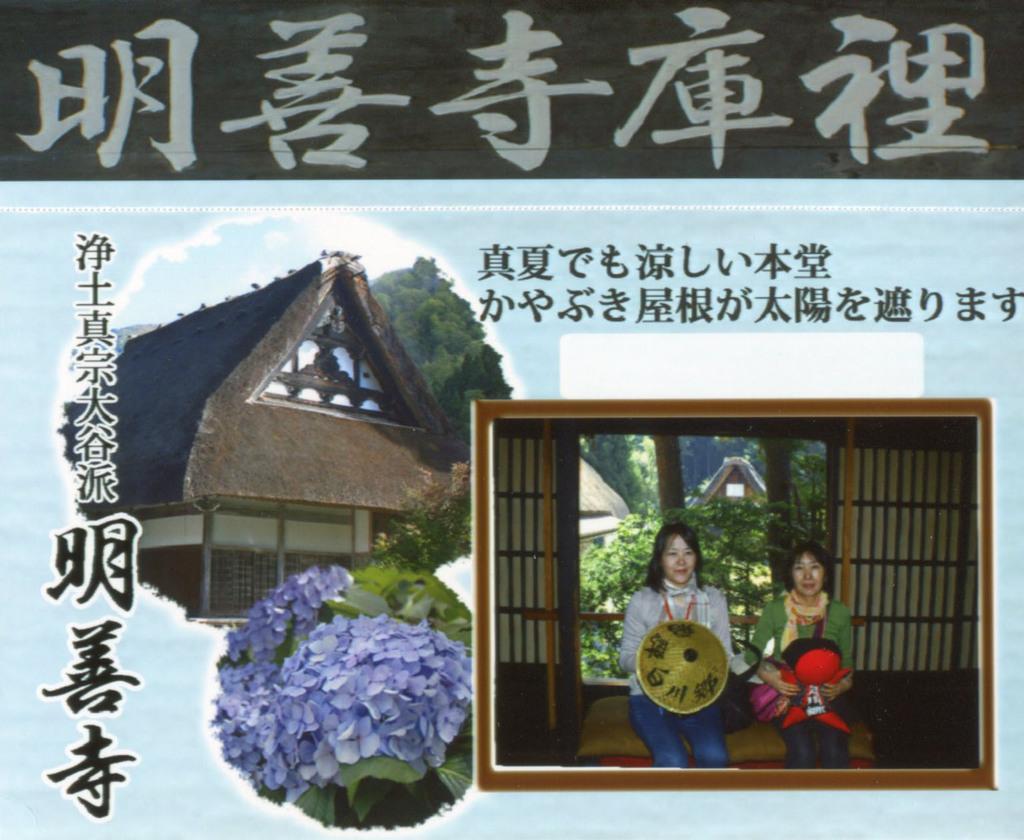Describe this image in one or two sentences. Here we can see poster,in this poster there are two women sitting and holding an objects and we can see house,trees and plants 